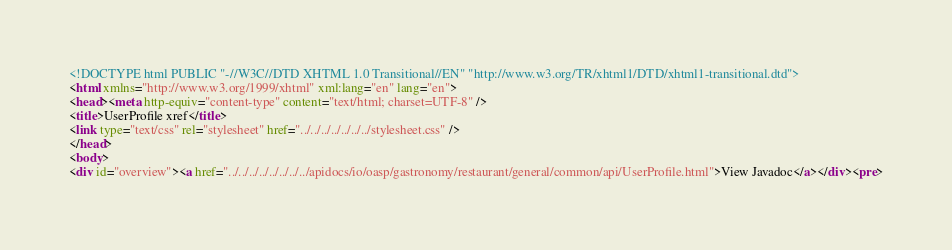<code> <loc_0><loc_0><loc_500><loc_500><_HTML_><!DOCTYPE html PUBLIC "-//W3C//DTD XHTML 1.0 Transitional//EN" "http://www.w3.org/TR/xhtml1/DTD/xhtml1-transitional.dtd">
<html xmlns="http://www.w3.org/1999/xhtml" xml:lang="en" lang="en">
<head><meta http-equiv="content-type" content="text/html; charset=UTF-8" />
<title>UserProfile xref</title>
<link type="text/css" rel="stylesheet" href="../../../../../../../stylesheet.css" />
</head>
<body>
<div id="overview"><a href="../../../../../../../../apidocs/io/oasp/gastronomy/restaurant/general/common/api/UserProfile.html">View Javadoc</a></div><pre></code> 